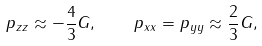Convert formula to latex. <formula><loc_0><loc_0><loc_500><loc_500>p _ { z z } \approx - \frac { 4 } { 3 } G , \quad p _ { x x } = p _ { y y } \approx \frac { 2 } { 3 } G ,</formula> 